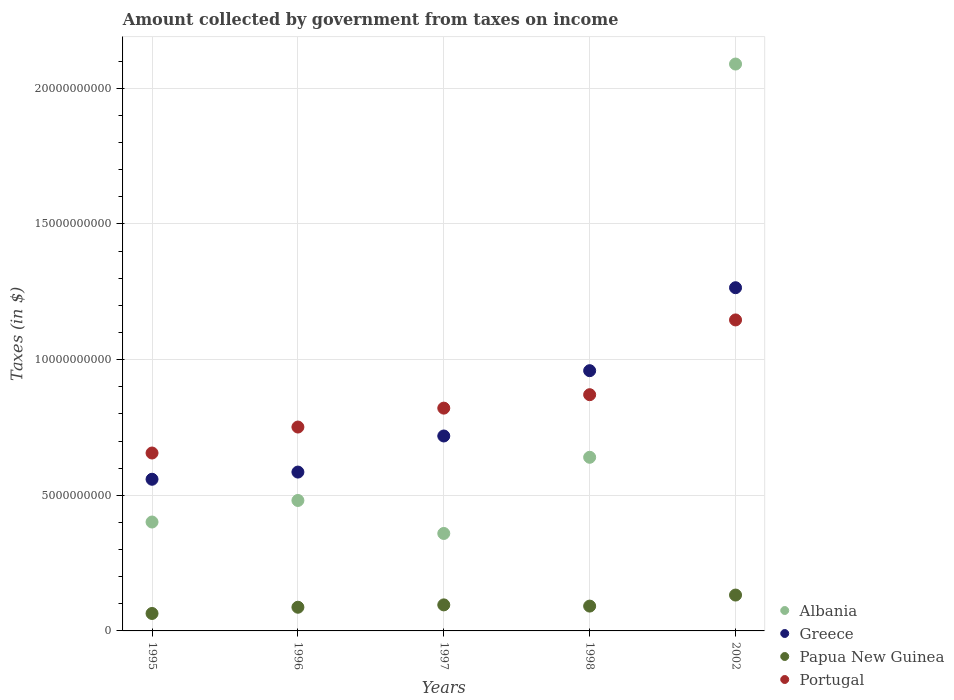What is the amount collected by government from taxes on income in Albania in 1997?
Provide a succinct answer. 3.59e+09. Across all years, what is the maximum amount collected by government from taxes on income in Papua New Guinea?
Your answer should be compact. 1.32e+09. Across all years, what is the minimum amount collected by government from taxes on income in Albania?
Give a very brief answer. 3.59e+09. In which year was the amount collected by government from taxes on income in Albania maximum?
Keep it short and to the point. 2002. What is the total amount collected by government from taxes on income in Papua New Guinea in the graph?
Your answer should be compact. 4.71e+09. What is the difference between the amount collected by government from taxes on income in Papua New Guinea in 1997 and that in 2002?
Offer a very short reply. -3.62e+08. What is the difference between the amount collected by government from taxes on income in Greece in 1998 and the amount collected by government from taxes on income in Papua New Guinea in 2002?
Offer a very short reply. 8.27e+09. What is the average amount collected by government from taxes on income in Albania per year?
Give a very brief answer. 7.94e+09. In the year 1995, what is the difference between the amount collected by government from taxes on income in Portugal and amount collected by government from taxes on income in Greece?
Your answer should be compact. 9.67e+08. In how many years, is the amount collected by government from taxes on income in Greece greater than 6000000000 $?
Offer a terse response. 3. What is the ratio of the amount collected by government from taxes on income in Greece in 1995 to that in 2002?
Keep it short and to the point. 0.44. Is the difference between the amount collected by government from taxes on income in Portugal in 1995 and 1998 greater than the difference between the amount collected by government from taxes on income in Greece in 1995 and 1998?
Provide a short and direct response. Yes. What is the difference between the highest and the second highest amount collected by government from taxes on income in Papua New Guinea?
Keep it short and to the point. 3.62e+08. What is the difference between the highest and the lowest amount collected by government from taxes on income in Portugal?
Ensure brevity in your answer.  4.91e+09. Is it the case that in every year, the sum of the amount collected by government from taxes on income in Albania and amount collected by government from taxes on income in Portugal  is greater than the amount collected by government from taxes on income in Papua New Guinea?
Your answer should be very brief. Yes. Does the amount collected by government from taxes on income in Greece monotonically increase over the years?
Offer a terse response. Yes. What is the difference between two consecutive major ticks on the Y-axis?
Provide a short and direct response. 5.00e+09. Are the values on the major ticks of Y-axis written in scientific E-notation?
Ensure brevity in your answer.  No. Where does the legend appear in the graph?
Provide a succinct answer. Bottom right. How are the legend labels stacked?
Make the answer very short. Vertical. What is the title of the graph?
Give a very brief answer. Amount collected by government from taxes on income. Does "Sub-Saharan Africa (developing only)" appear as one of the legend labels in the graph?
Give a very brief answer. No. What is the label or title of the X-axis?
Your answer should be very brief. Years. What is the label or title of the Y-axis?
Give a very brief answer. Taxes (in $). What is the Taxes (in $) of Albania in 1995?
Make the answer very short. 4.01e+09. What is the Taxes (in $) in Greece in 1995?
Provide a short and direct response. 5.59e+09. What is the Taxes (in $) in Papua New Guinea in 1995?
Offer a terse response. 6.43e+08. What is the Taxes (in $) in Portugal in 1995?
Your answer should be very brief. 6.56e+09. What is the Taxes (in $) in Albania in 1996?
Keep it short and to the point. 4.81e+09. What is the Taxes (in $) of Greece in 1996?
Provide a short and direct response. 5.86e+09. What is the Taxes (in $) in Papua New Guinea in 1996?
Your answer should be compact. 8.73e+08. What is the Taxes (in $) of Portugal in 1996?
Make the answer very short. 7.51e+09. What is the Taxes (in $) in Albania in 1997?
Keep it short and to the point. 3.59e+09. What is the Taxes (in $) of Greece in 1997?
Provide a short and direct response. 7.18e+09. What is the Taxes (in $) of Papua New Guinea in 1997?
Your answer should be compact. 9.60e+08. What is the Taxes (in $) of Portugal in 1997?
Make the answer very short. 8.21e+09. What is the Taxes (in $) of Albania in 1998?
Keep it short and to the point. 6.40e+09. What is the Taxes (in $) in Greece in 1998?
Your answer should be very brief. 9.59e+09. What is the Taxes (in $) in Papua New Guinea in 1998?
Keep it short and to the point. 9.15e+08. What is the Taxes (in $) of Portugal in 1998?
Keep it short and to the point. 8.71e+09. What is the Taxes (in $) of Albania in 2002?
Make the answer very short. 2.09e+1. What is the Taxes (in $) of Greece in 2002?
Ensure brevity in your answer.  1.26e+1. What is the Taxes (in $) of Papua New Guinea in 2002?
Offer a terse response. 1.32e+09. What is the Taxes (in $) of Portugal in 2002?
Ensure brevity in your answer.  1.15e+1. Across all years, what is the maximum Taxes (in $) in Albania?
Your answer should be very brief. 2.09e+1. Across all years, what is the maximum Taxes (in $) of Greece?
Keep it short and to the point. 1.26e+1. Across all years, what is the maximum Taxes (in $) in Papua New Guinea?
Provide a succinct answer. 1.32e+09. Across all years, what is the maximum Taxes (in $) in Portugal?
Give a very brief answer. 1.15e+1. Across all years, what is the minimum Taxes (in $) of Albania?
Ensure brevity in your answer.  3.59e+09. Across all years, what is the minimum Taxes (in $) of Greece?
Your response must be concise. 5.59e+09. Across all years, what is the minimum Taxes (in $) in Papua New Guinea?
Offer a very short reply. 6.43e+08. Across all years, what is the minimum Taxes (in $) of Portugal?
Offer a very short reply. 6.56e+09. What is the total Taxes (in $) in Albania in the graph?
Keep it short and to the point. 3.97e+1. What is the total Taxes (in $) of Greece in the graph?
Keep it short and to the point. 4.09e+1. What is the total Taxes (in $) in Papua New Guinea in the graph?
Offer a terse response. 4.71e+09. What is the total Taxes (in $) in Portugal in the graph?
Provide a short and direct response. 4.25e+1. What is the difference between the Taxes (in $) in Albania in 1995 and that in 1996?
Make the answer very short. -7.94e+08. What is the difference between the Taxes (in $) of Greece in 1995 and that in 1996?
Provide a succinct answer. -2.65e+08. What is the difference between the Taxes (in $) of Papua New Guinea in 1995 and that in 1996?
Provide a succinct answer. -2.30e+08. What is the difference between the Taxes (in $) in Portugal in 1995 and that in 1996?
Offer a very short reply. -9.57e+08. What is the difference between the Taxes (in $) in Albania in 1995 and that in 1997?
Your response must be concise. 4.22e+08. What is the difference between the Taxes (in $) in Greece in 1995 and that in 1997?
Your answer should be very brief. -1.60e+09. What is the difference between the Taxes (in $) in Papua New Guinea in 1995 and that in 1997?
Give a very brief answer. -3.16e+08. What is the difference between the Taxes (in $) of Portugal in 1995 and that in 1997?
Your response must be concise. -1.65e+09. What is the difference between the Taxes (in $) of Albania in 1995 and that in 1998?
Your response must be concise. -2.39e+09. What is the difference between the Taxes (in $) in Greece in 1995 and that in 1998?
Provide a short and direct response. -4.00e+09. What is the difference between the Taxes (in $) in Papua New Guinea in 1995 and that in 1998?
Offer a terse response. -2.72e+08. What is the difference between the Taxes (in $) in Portugal in 1995 and that in 1998?
Provide a short and direct response. -2.15e+09. What is the difference between the Taxes (in $) of Albania in 1995 and that in 2002?
Offer a terse response. -1.69e+1. What is the difference between the Taxes (in $) in Greece in 1995 and that in 2002?
Your response must be concise. -7.06e+09. What is the difference between the Taxes (in $) of Papua New Guinea in 1995 and that in 2002?
Give a very brief answer. -6.79e+08. What is the difference between the Taxes (in $) in Portugal in 1995 and that in 2002?
Keep it short and to the point. -4.91e+09. What is the difference between the Taxes (in $) in Albania in 1996 and that in 1997?
Make the answer very short. 1.22e+09. What is the difference between the Taxes (in $) in Greece in 1996 and that in 1997?
Your answer should be very brief. -1.33e+09. What is the difference between the Taxes (in $) of Papua New Guinea in 1996 and that in 1997?
Your response must be concise. -8.66e+07. What is the difference between the Taxes (in $) in Portugal in 1996 and that in 1997?
Give a very brief answer. -6.97e+08. What is the difference between the Taxes (in $) in Albania in 1996 and that in 1998?
Provide a short and direct response. -1.59e+09. What is the difference between the Taxes (in $) of Greece in 1996 and that in 1998?
Offer a terse response. -3.74e+09. What is the difference between the Taxes (in $) in Papua New Guinea in 1996 and that in 1998?
Your answer should be very brief. -4.20e+07. What is the difference between the Taxes (in $) of Portugal in 1996 and that in 1998?
Give a very brief answer. -1.19e+09. What is the difference between the Taxes (in $) in Albania in 1996 and that in 2002?
Your answer should be very brief. -1.61e+1. What is the difference between the Taxes (in $) of Greece in 1996 and that in 2002?
Keep it short and to the point. -6.80e+09. What is the difference between the Taxes (in $) of Papua New Guinea in 1996 and that in 2002?
Offer a terse response. -4.49e+08. What is the difference between the Taxes (in $) in Portugal in 1996 and that in 2002?
Provide a short and direct response. -3.95e+09. What is the difference between the Taxes (in $) in Albania in 1997 and that in 1998?
Make the answer very short. -2.81e+09. What is the difference between the Taxes (in $) of Greece in 1997 and that in 1998?
Offer a very short reply. -2.41e+09. What is the difference between the Taxes (in $) in Papua New Guinea in 1997 and that in 1998?
Your answer should be compact. 4.47e+07. What is the difference between the Taxes (in $) in Portugal in 1997 and that in 1998?
Keep it short and to the point. -4.95e+08. What is the difference between the Taxes (in $) in Albania in 1997 and that in 2002?
Offer a very short reply. -1.73e+1. What is the difference between the Taxes (in $) of Greece in 1997 and that in 2002?
Provide a short and direct response. -5.46e+09. What is the difference between the Taxes (in $) of Papua New Guinea in 1997 and that in 2002?
Your answer should be very brief. -3.62e+08. What is the difference between the Taxes (in $) in Portugal in 1997 and that in 2002?
Keep it short and to the point. -3.25e+09. What is the difference between the Taxes (in $) of Albania in 1998 and that in 2002?
Give a very brief answer. -1.45e+1. What is the difference between the Taxes (in $) in Greece in 1998 and that in 2002?
Give a very brief answer. -3.06e+09. What is the difference between the Taxes (in $) of Papua New Guinea in 1998 and that in 2002?
Provide a succinct answer. -4.07e+08. What is the difference between the Taxes (in $) in Portugal in 1998 and that in 2002?
Provide a short and direct response. -2.76e+09. What is the difference between the Taxes (in $) of Albania in 1995 and the Taxes (in $) of Greece in 1996?
Offer a very short reply. -1.84e+09. What is the difference between the Taxes (in $) of Albania in 1995 and the Taxes (in $) of Papua New Guinea in 1996?
Provide a short and direct response. 3.14e+09. What is the difference between the Taxes (in $) of Albania in 1995 and the Taxes (in $) of Portugal in 1996?
Your response must be concise. -3.50e+09. What is the difference between the Taxes (in $) in Greece in 1995 and the Taxes (in $) in Papua New Guinea in 1996?
Provide a succinct answer. 4.72e+09. What is the difference between the Taxes (in $) in Greece in 1995 and the Taxes (in $) in Portugal in 1996?
Offer a very short reply. -1.92e+09. What is the difference between the Taxes (in $) in Papua New Guinea in 1995 and the Taxes (in $) in Portugal in 1996?
Offer a very short reply. -6.87e+09. What is the difference between the Taxes (in $) of Albania in 1995 and the Taxes (in $) of Greece in 1997?
Your answer should be compact. -3.17e+09. What is the difference between the Taxes (in $) in Albania in 1995 and the Taxes (in $) in Papua New Guinea in 1997?
Provide a short and direct response. 3.05e+09. What is the difference between the Taxes (in $) in Albania in 1995 and the Taxes (in $) in Portugal in 1997?
Your answer should be compact. -4.20e+09. What is the difference between the Taxes (in $) in Greece in 1995 and the Taxes (in $) in Papua New Guinea in 1997?
Your answer should be compact. 4.63e+09. What is the difference between the Taxes (in $) in Greece in 1995 and the Taxes (in $) in Portugal in 1997?
Give a very brief answer. -2.62e+09. What is the difference between the Taxes (in $) in Papua New Guinea in 1995 and the Taxes (in $) in Portugal in 1997?
Give a very brief answer. -7.57e+09. What is the difference between the Taxes (in $) of Albania in 1995 and the Taxes (in $) of Greece in 1998?
Your response must be concise. -5.58e+09. What is the difference between the Taxes (in $) of Albania in 1995 and the Taxes (in $) of Papua New Guinea in 1998?
Make the answer very short. 3.10e+09. What is the difference between the Taxes (in $) of Albania in 1995 and the Taxes (in $) of Portugal in 1998?
Provide a succinct answer. -4.69e+09. What is the difference between the Taxes (in $) of Greece in 1995 and the Taxes (in $) of Papua New Guinea in 1998?
Ensure brevity in your answer.  4.67e+09. What is the difference between the Taxes (in $) in Greece in 1995 and the Taxes (in $) in Portugal in 1998?
Your answer should be compact. -3.12e+09. What is the difference between the Taxes (in $) of Papua New Guinea in 1995 and the Taxes (in $) of Portugal in 1998?
Your answer should be very brief. -8.06e+09. What is the difference between the Taxes (in $) of Albania in 1995 and the Taxes (in $) of Greece in 2002?
Your answer should be compact. -8.64e+09. What is the difference between the Taxes (in $) in Albania in 1995 and the Taxes (in $) in Papua New Guinea in 2002?
Your answer should be very brief. 2.69e+09. What is the difference between the Taxes (in $) of Albania in 1995 and the Taxes (in $) of Portugal in 2002?
Offer a very short reply. -7.45e+09. What is the difference between the Taxes (in $) in Greece in 1995 and the Taxes (in $) in Papua New Guinea in 2002?
Provide a short and direct response. 4.27e+09. What is the difference between the Taxes (in $) of Greece in 1995 and the Taxes (in $) of Portugal in 2002?
Provide a short and direct response. -5.87e+09. What is the difference between the Taxes (in $) of Papua New Guinea in 1995 and the Taxes (in $) of Portugal in 2002?
Offer a terse response. -1.08e+1. What is the difference between the Taxes (in $) of Albania in 1996 and the Taxes (in $) of Greece in 1997?
Make the answer very short. -2.38e+09. What is the difference between the Taxes (in $) of Albania in 1996 and the Taxes (in $) of Papua New Guinea in 1997?
Give a very brief answer. 3.85e+09. What is the difference between the Taxes (in $) of Albania in 1996 and the Taxes (in $) of Portugal in 1997?
Provide a succinct answer. -3.40e+09. What is the difference between the Taxes (in $) of Greece in 1996 and the Taxes (in $) of Papua New Guinea in 1997?
Offer a very short reply. 4.90e+09. What is the difference between the Taxes (in $) in Greece in 1996 and the Taxes (in $) in Portugal in 1997?
Provide a short and direct response. -2.36e+09. What is the difference between the Taxes (in $) of Papua New Guinea in 1996 and the Taxes (in $) of Portugal in 1997?
Make the answer very short. -7.34e+09. What is the difference between the Taxes (in $) of Albania in 1996 and the Taxes (in $) of Greece in 1998?
Offer a terse response. -4.78e+09. What is the difference between the Taxes (in $) of Albania in 1996 and the Taxes (in $) of Papua New Guinea in 1998?
Make the answer very short. 3.89e+09. What is the difference between the Taxes (in $) of Albania in 1996 and the Taxes (in $) of Portugal in 1998?
Make the answer very short. -3.90e+09. What is the difference between the Taxes (in $) in Greece in 1996 and the Taxes (in $) in Papua New Guinea in 1998?
Your answer should be very brief. 4.94e+09. What is the difference between the Taxes (in $) of Greece in 1996 and the Taxes (in $) of Portugal in 1998?
Give a very brief answer. -2.85e+09. What is the difference between the Taxes (in $) in Papua New Guinea in 1996 and the Taxes (in $) in Portugal in 1998?
Your response must be concise. -7.83e+09. What is the difference between the Taxes (in $) in Albania in 1996 and the Taxes (in $) in Greece in 2002?
Give a very brief answer. -7.84e+09. What is the difference between the Taxes (in $) in Albania in 1996 and the Taxes (in $) in Papua New Guinea in 2002?
Ensure brevity in your answer.  3.49e+09. What is the difference between the Taxes (in $) in Albania in 1996 and the Taxes (in $) in Portugal in 2002?
Your response must be concise. -6.65e+09. What is the difference between the Taxes (in $) in Greece in 1996 and the Taxes (in $) in Papua New Guinea in 2002?
Offer a terse response. 4.53e+09. What is the difference between the Taxes (in $) of Greece in 1996 and the Taxes (in $) of Portugal in 2002?
Ensure brevity in your answer.  -5.61e+09. What is the difference between the Taxes (in $) of Papua New Guinea in 1996 and the Taxes (in $) of Portugal in 2002?
Provide a short and direct response. -1.06e+1. What is the difference between the Taxes (in $) in Albania in 1997 and the Taxes (in $) in Greece in 1998?
Offer a very short reply. -6.00e+09. What is the difference between the Taxes (in $) in Albania in 1997 and the Taxes (in $) in Papua New Guinea in 1998?
Ensure brevity in your answer.  2.68e+09. What is the difference between the Taxes (in $) of Albania in 1997 and the Taxes (in $) of Portugal in 1998?
Make the answer very short. -5.11e+09. What is the difference between the Taxes (in $) in Greece in 1997 and the Taxes (in $) in Papua New Guinea in 1998?
Offer a very short reply. 6.27e+09. What is the difference between the Taxes (in $) in Greece in 1997 and the Taxes (in $) in Portugal in 1998?
Your response must be concise. -1.52e+09. What is the difference between the Taxes (in $) in Papua New Guinea in 1997 and the Taxes (in $) in Portugal in 1998?
Make the answer very short. -7.75e+09. What is the difference between the Taxes (in $) in Albania in 1997 and the Taxes (in $) in Greece in 2002?
Give a very brief answer. -9.06e+09. What is the difference between the Taxes (in $) of Albania in 1997 and the Taxes (in $) of Papua New Guinea in 2002?
Offer a terse response. 2.27e+09. What is the difference between the Taxes (in $) of Albania in 1997 and the Taxes (in $) of Portugal in 2002?
Give a very brief answer. -7.87e+09. What is the difference between the Taxes (in $) in Greece in 1997 and the Taxes (in $) in Papua New Guinea in 2002?
Provide a short and direct response. 5.86e+09. What is the difference between the Taxes (in $) of Greece in 1997 and the Taxes (in $) of Portugal in 2002?
Your answer should be compact. -4.28e+09. What is the difference between the Taxes (in $) of Papua New Guinea in 1997 and the Taxes (in $) of Portugal in 2002?
Offer a terse response. -1.05e+1. What is the difference between the Taxes (in $) in Albania in 1998 and the Taxes (in $) in Greece in 2002?
Your response must be concise. -6.25e+09. What is the difference between the Taxes (in $) in Albania in 1998 and the Taxes (in $) in Papua New Guinea in 2002?
Provide a short and direct response. 5.08e+09. What is the difference between the Taxes (in $) in Albania in 1998 and the Taxes (in $) in Portugal in 2002?
Provide a short and direct response. -5.06e+09. What is the difference between the Taxes (in $) of Greece in 1998 and the Taxes (in $) of Papua New Guinea in 2002?
Keep it short and to the point. 8.27e+09. What is the difference between the Taxes (in $) of Greece in 1998 and the Taxes (in $) of Portugal in 2002?
Ensure brevity in your answer.  -1.87e+09. What is the difference between the Taxes (in $) of Papua New Guinea in 1998 and the Taxes (in $) of Portugal in 2002?
Provide a short and direct response. -1.05e+1. What is the average Taxes (in $) in Albania per year?
Give a very brief answer. 7.94e+09. What is the average Taxes (in $) in Greece per year?
Ensure brevity in your answer.  8.17e+09. What is the average Taxes (in $) of Papua New Guinea per year?
Your answer should be very brief. 9.43e+08. What is the average Taxes (in $) in Portugal per year?
Your response must be concise. 8.49e+09. In the year 1995, what is the difference between the Taxes (in $) of Albania and Taxes (in $) of Greece?
Ensure brevity in your answer.  -1.58e+09. In the year 1995, what is the difference between the Taxes (in $) in Albania and Taxes (in $) in Papua New Guinea?
Your answer should be compact. 3.37e+09. In the year 1995, what is the difference between the Taxes (in $) of Albania and Taxes (in $) of Portugal?
Offer a very short reply. -2.54e+09. In the year 1995, what is the difference between the Taxes (in $) in Greece and Taxes (in $) in Papua New Guinea?
Make the answer very short. 4.95e+09. In the year 1995, what is the difference between the Taxes (in $) of Greece and Taxes (in $) of Portugal?
Offer a terse response. -9.67e+08. In the year 1995, what is the difference between the Taxes (in $) of Papua New Guinea and Taxes (in $) of Portugal?
Your response must be concise. -5.91e+09. In the year 1996, what is the difference between the Taxes (in $) of Albania and Taxes (in $) of Greece?
Your answer should be very brief. -1.05e+09. In the year 1996, what is the difference between the Taxes (in $) in Albania and Taxes (in $) in Papua New Guinea?
Your response must be concise. 3.94e+09. In the year 1996, what is the difference between the Taxes (in $) of Albania and Taxes (in $) of Portugal?
Give a very brief answer. -2.71e+09. In the year 1996, what is the difference between the Taxes (in $) of Greece and Taxes (in $) of Papua New Guinea?
Ensure brevity in your answer.  4.98e+09. In the year 1996, what is the difference between the Taxes (in $) of Greece and Taxes (in $) of Portugal?
Ensure brevity in your answer.  -1.66e+09. In the year 1996, what is the difference between the Taxes (in $) of Papua New Guinea and Taxes (in $) of Portugal?
Your answer should be very brief. -6.64e+09. In the year 1997, what is the difference between the Taxes (in $) of Albania and Taxes (in $) of Greece?
Your answer should be compact. -3.59e+09. In the year 1997, what is the difference between the Taxes (in $) of Albania and Taxes (in $) of Papua New Guinea?
Your answer should be very brief. 2.63e+09. In the year 1997, what is the difference between the Taxes (in $) of Albania and Taxes (in $) of Portugal?
Ensure brevity in your answer.  -4.62e+09. In the year 1997, what is the difference between the Taxes (in $) of Greece and Taxes (in $) of Papua New Guinea?
Offer a terse response. 6.23e+09. In the year 1997, what is the difference between the Taxes (in $) of Greece and Taxes (in $) of Portugal?
Give a very brief answer. -1.03e+09. In the year 1997, what is the difference between the Taxes (in $) of Papua New Guinea and Taxes (in $) of Portugal?
Provide a short and direct response. -7.25e+09. In the year 1998, what is the difference between the Taxes (in $) in Albania and Taxes (in $) in Greece?
Ensure brevity in your answer.  -3.19e+09. In the year 1998, what is the difference between the Taxes (in $) of Albania and Taxes (in $) of Papua New Guinea?
Your response must be concise. 5.48e+09. In the year 1998, what is the difference between the Taxes (in $) of Albania and Taxes (in $) of Portugal?
Make the answer very short. -2.31e+09. In the year 1998, what is the difference between the Taxes (in $) in Greece and Taxes (in $) in Papua New Guinea?
Provide a short and direct response. 8.68e+09. In the year 1998, what is the difference between the Taxes (in $) in Greece and Taxes (in $) in Portugal?
Your response must be concise. 8.85e+08. In the year 1998, what is the difference between the Taxes (in $) in Papua New Guinea and Taxes (in $) in Portugal?
Offer a very short reply. -7.79e+09. In the year 2002, what is the difference between the Taxes (in $) in Albania and Taxes (in $) in Greece?
Your answer should be very brief. 8.24e+09. In the year 2002, what is the difference between the Taxes (in $) of Albania and Taxes (in $) of Papua New Guinea?
Offer a terse response. 1.96e+1. In the year 2002, what is the difference between the Taxes (in $) of Albania and Taxes (in $) of Portugal?
Keep it short and to the point. 9.43e+09. In the year 2002, what is the difference between the Taxes (in $) in Greece and Taxes (in $) in Papua New Guinea?
Provide a short and direct response. 1.13e+1. In the year 2002, what is the difference between the Taxes (in $) in Greece and Taxes (in $) in Portugal?
Offer a very short reply. 1.19e+09. In the year 2002, what is the difference between the Taxes (in $) in Papua New Guinea and Taxes (in $) in Portugal?
Your answer should be compact. -1.01e+1. What is the ratio of the Taxes (in $) of Albania in 1995 to that in 1996?
Ensure brevity in your answer.  0.83. What is the ratio of the Taxes (in $) of Greece in 1995 to that in 1996?
Give a very brief answer. 0.95. What is the ratio of the Taxes (in $) in Papua New Guinea in 1995 to that in 1996?
Your answer should be very brief. 0.74. What is the ratio of the Taxes (in $) of Portugal in 1995 to that in 1996?
Your answer should be compact. 0.87. What is the ratio of the Taxes (in $) in Albania in 1995 to that in 1997?
Ensure brevity in your answer.  1.12. What is the ratio of the Taxes (in $) of Greece in 1995 to that in 1997?
Give a very brief answer. 0.78. What is the ratio of the Taxes (in $) of Papua New Guinea in 1995 to that in 1997?
Offer a terse response. 0.67. What is the ratio of the Taxes (in $) in Portugal in 1995 to that in 1997?
Provide a short and direct response. 0.8. What is the ratio of the Taxes (in $) of Albania in 1995 to that in 1998?
Your response must be concise. 0.63. What is the ratio of the Taxes (in $) of Greece in 1995 to that in 1998?
Provide a succinct answer. 0.58. What is the ratio of the Taxes (in $) in Papua New Guinea in 1995 to that in 1998?
Ensure brevity in your answer.  0.7. What is the ratio of the Taxes (in $) in Portugal in 1995 to that in 1998?
Offer a terse response. 0.75. What is the ratio of the Taxes (in $) in Albania in 1995 to that in 2002?
Your answer should be very brief. 0.19. What is the ratio of the Taxes (in $) of Greece in 1995 to that in 2002?
Your response must be concise. 0.44. What is the ratio of the Taxes (in $) of Papua New Guinea in 1995 to that in 2002?
Provide a short and direct response. 0.49. What is the ratio of the Taxes (in $) in Portugal in 1995 to that in 2002?
Make the answer very short. 0.57. What is the ratio of the Taxes (in $) of Albania in 1996 to that in 1997?
Provide a short and direct response. 1.34. What is the ratio of the Taxes (in $) of Greece in 1996 to that in 1997?
Offer a terse response. 0.81. What is the ratio of the Taxes (in $) in Papua New Guinea in 1996 to that in 1997?
Your response must be concise. 0.91. What is the ratio of the Taxes (in $) of Portugal in 1996 to that in 1997?
Your response must be concise. 0.92. What is the ratio of the Taxes (in $) in Albania in 1996 to that in 1998?
Your response must be concise. 0.75. What is the ratio of the Taxes (in $) of Greece in 1996 to that in 1998?
Your answer should be very brief. 0.61. What is the ratio of the Taxes (in $) of Papua New Guinea in 1996 to that in 1998?
Your response must be concise. 0.95. What is the ratio of the Taxes (in $) of Portugal in 1996 to that in 1998?
Your response must be concise. 0.86. What is the ratio of the Taxes (in $) of Albania in 1996 to that in 2002?
Offer a very short reply. 0.23. What is the ratio of the Taxes (in $) of Greece in 1996 to that in 2002?
Give a very brief answer. 0.46. What is the ratio of the Taxes (in $) of Papua New Guinea in 1996 to that in 2002?
Ensure brevity in your answer.  0.66. What is the ratio of the Taxes (in $) of Portugal in 1996 to that in 2002?
Ensure brevity in your answer.  0.66. What is the ratio of the Taxes (in $) of Albania in 1997 to that in 1998?
Your response must be concise. 0.56. What is the ratio of the Taxes (in $) in Greece in 1997 to that in 1998?
Offer a very short reply. 0.75. What is the ratio of the Taxes (in $) in Papua New Guinea in 1997 to that in 1998?
Your response must be concise. 1.05. What is the ratio of the Taxes (in $) in Portugal in 1997 to that in 1998?
Provide a succinct answer. 0.94. What is the ratio of the Taxes (in $) of Albania in 1997 to that in 2002?
Offer a terse response. 0.17. What is the ratio of the Taxes (in $) in Greece in 1997 to that in 2002?
Your answer should be compact. 0.57. What is the ratio of the Taxes (in $) of Papua New Guinea in 1997 to that in 2002?
Provide a succinct answer. 0.73. What is the ratio of the Taxes (in $) in Portugal in 1997 to that in 2002?
Offer a terse response. 0.72. What is the ratio of the Taxes (in $) of Albania in 1998 to that in 2002?
Keep it short and to the point. 0.31. What is the ratio of the Taxes (in $) of Greece in 1998 to that in 2002?
Keep it short and to the point. 0.76. What is the ratio of the Taxes (in $) in Papua New Guinea in 1998 to that in 2002?
Keep it short and to the point. 0.69. What is the ratio of the Taxes (in $) in Portugal in 1998 to that in 2002?
Your response must be concise. 0.76. What is the difference between the highest and the second highest Taxes (in $) in Albania?
Offer a very short reply. 1.45e+1. What is the difference between the highest and the second highest Taxes (in $) of Greece?
Offer a terse response. 3.06e+09. What is the difference between the highest and the second highest Taxes (in $) of Papua New Guinea?
Give a very brief answer. 3.62e+08. What is the difference between the highest and the second highest Taxes (in $) of Portugal?
Your answer should be very brief. 2.76e+09. What is the difference between the highest and the lowest Taxes (in $) in Albania?
Offer a very short reply. 1.73e+1. What is the difference between the highest and the lowest Taxes (in $) of Greece?
Provide a succinct answer. 7.06e+09. What is the difference between the highest and the lowest Taxes (in $) in Papua New Guinea?
Make the answer very short. 6.79e+08. What is the difference between the highest and the lowest Taxes (in $) in Portugal?
Provide a short and direct response. 4.91e+09. 